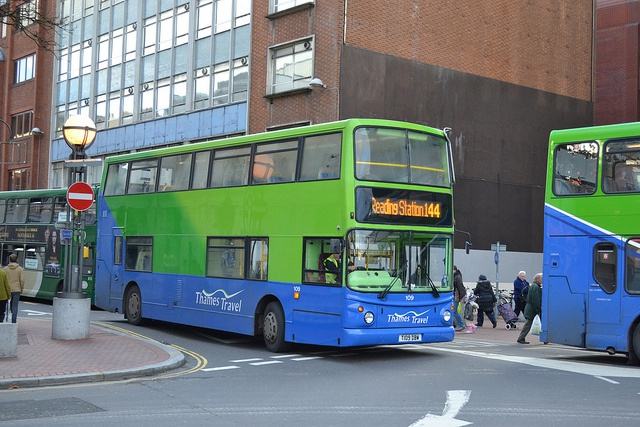Describe the objects in this image and their specific colors. I can see bus in gray, black, green, and blue tones, bus in gray, blue, and green tones, bus in gray, black, teal, and darkgray tones, people in gray, black, and darkgreen tones, and people in gray, black, purple, and darkblue tones in this image. 